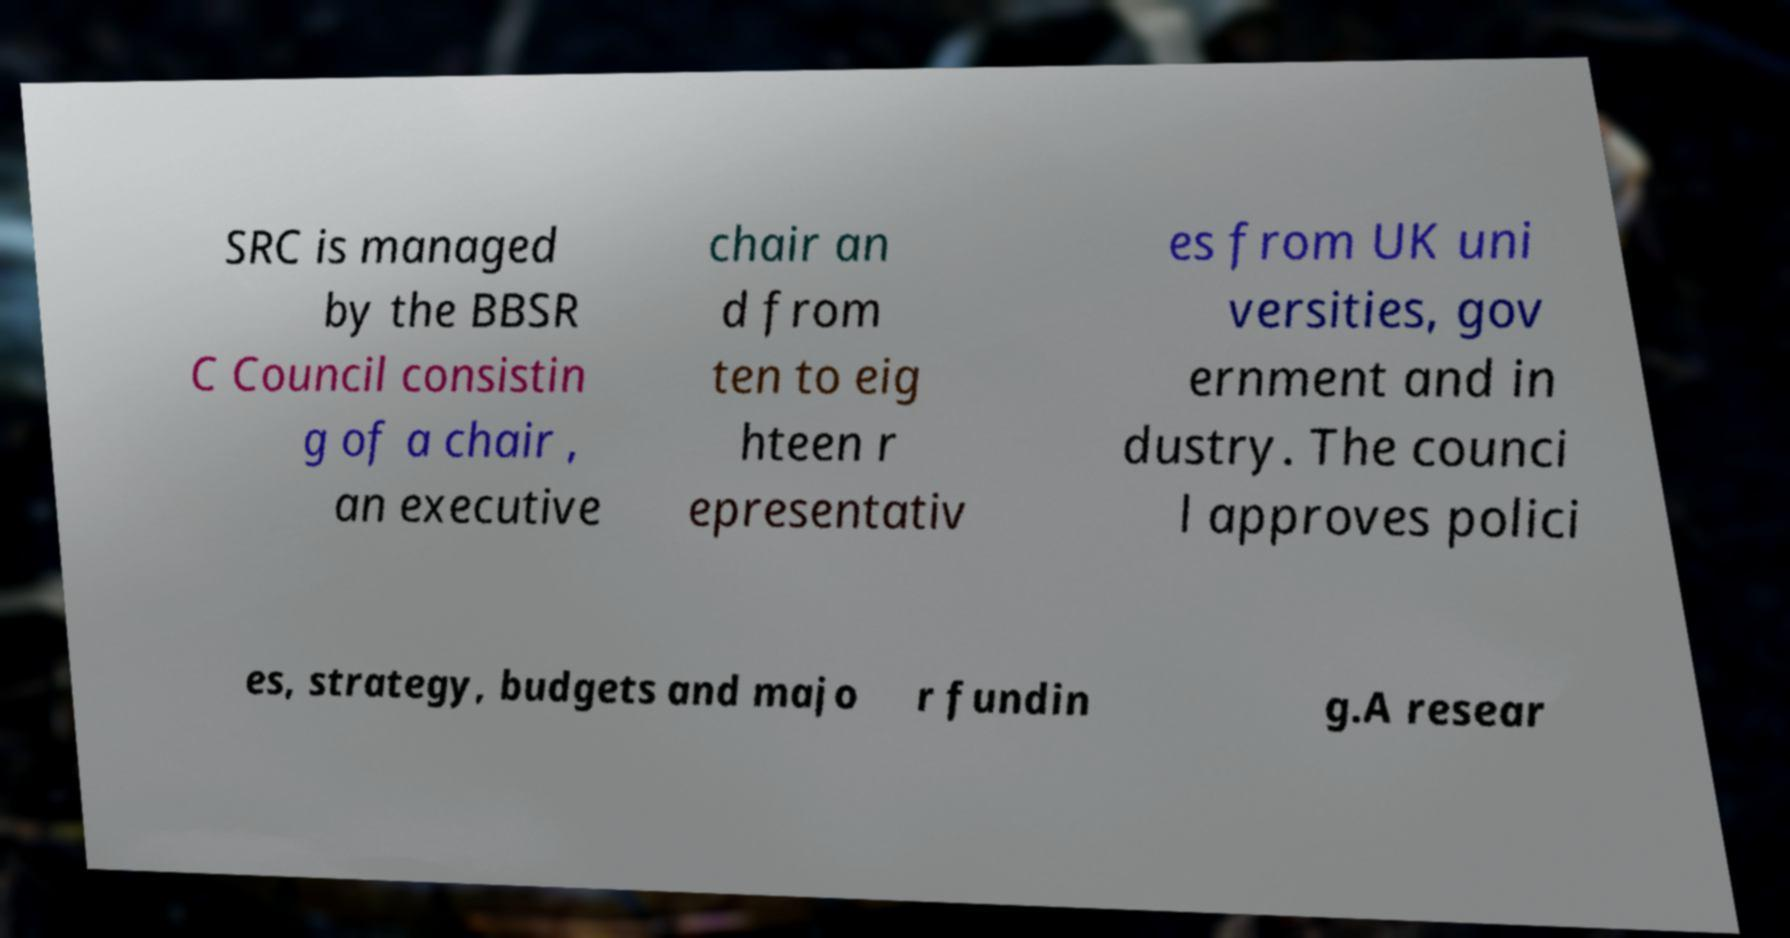There's text embedded in this image that I need extracted. Can you transcribe it verbatim? SRC is managed by the BBSR C Council consistin g of a chair , an executive chair an d from ten to eig hteen r epresentativ es from UK uni versities, gov ernment and in dustry. The counci l approves polici es, strategy, budgets and majo r fundin g.A resear 